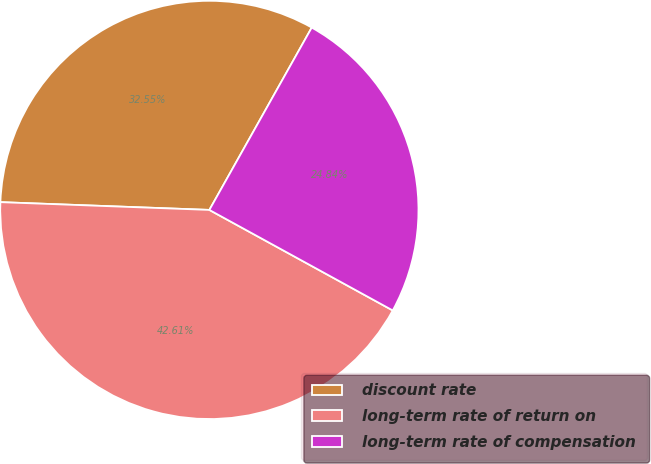<chart> <loc_0><loc_0><loc_500><loc_500><pie_chart><fcel>discount rate<fcel>long-term rate of return on<fcel>long-term rate of compensation<nl><fcel>32.55%<fcel>42.61%<fcel>24.84%<nl></chart> 